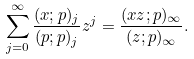Convert formula to latex. <formula><loc_0><loc_0><loc_500><loc_500>\sum _ { j = 0 } ^ { \infty } \frac { ( x ; p ) _ { j } } { ( p ; p ) _ { j } } z ^ { j } = \frac { ( x z ; p ) _ { \infty } } { ( z ; p ) _ { \infty } } .</formula> 